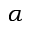<formula> <loc_0><loc_0><loc_500><loc_500>\alpha</formula> 